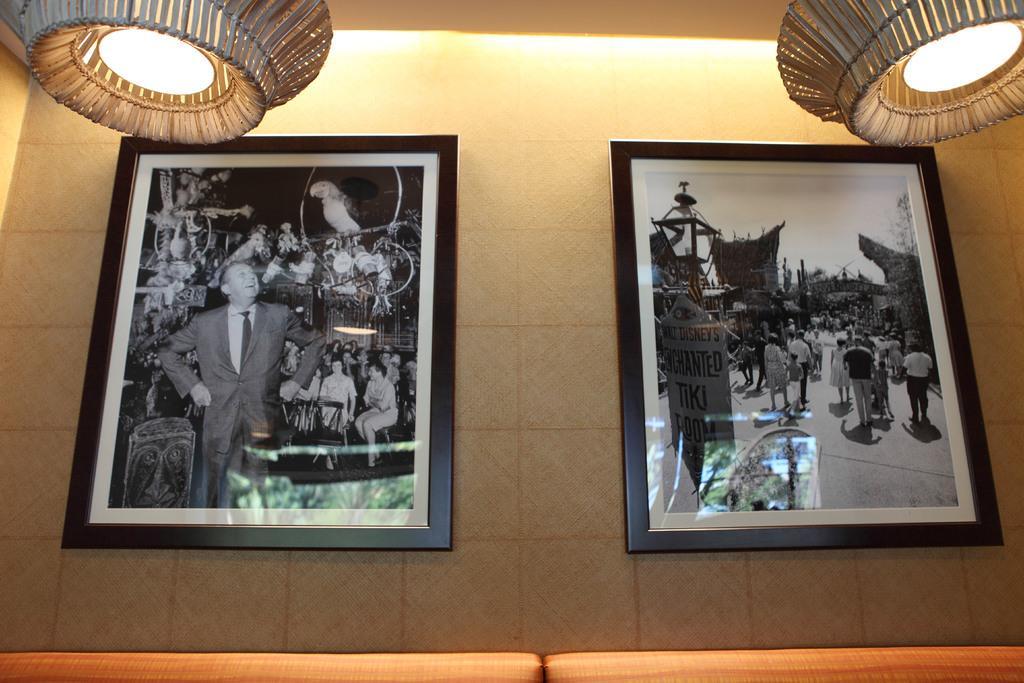Could you give a brief overview of what you see in this image? In the picture we can see two photo frames on the wall, in the photo frames we can see people, there are lights. 